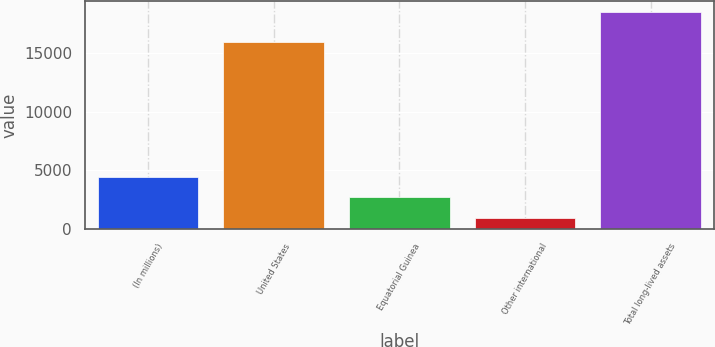Convert chart. <chart><loc_0><loc_0><loc_500><loc_500><bar_chart><fcel>(In millions)<fcel>United States<fcel>Equatorial Guinea<fcel>Other international<fcel>Total long-lived assets<nl><fcel>4469.6<fcel>15971<fcel>2714.3<fcel>959<fcel>18512<nl></chart> 